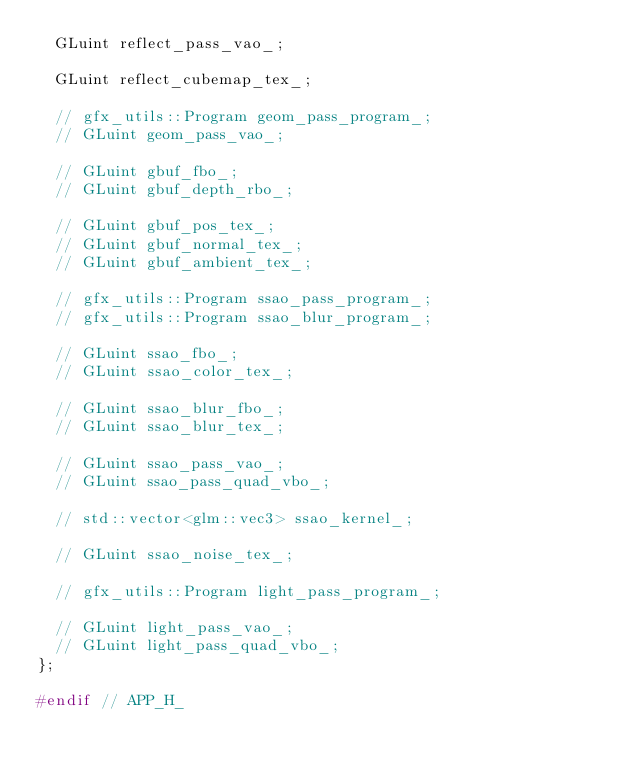Convert code to text. <code><loc_0><loc_0><loc_500><loc_500><_C_>  GLuint reflect_pass_vao_;

  GLuint reflect_cubemap_tex_;

  // gfx_utils::Program geom_pass_program_;
  // GLuint geom_pass_vao_;

  // GLuint gbuf_fbo_;
  // GLuint gbuf_depth_rbo_;

  // GLuint gbuf_pos_tex_;
  // GLuint gbuf_normal_tex_;
  // GLuint gbuf_ambient_tex_;

  // gfx_utils::Program ssao_pass_program_;
  // gfx_utils::Program ssao_blur_program_;

  // GLuint ssao_fbo_;
  // GLuint ssao_color_tex_;

  // GLuint ssao_blur_fbo_;
  // GLuint ssao_blur_tex_;

  // GLuint ssao_pass_vao_;
  // GLuint ssao_pass_quad_vbo_;

  // std::vector<glm::vec3> ssao_kernel_;

  // GLuint ssao_noise_tex_;

  // gfx_utils::Program light_pass_program_;

  // GLuint light_pass_vao_;
  // GLuint light_pass_quad_vbo_;
};

#endif // APP_H_</code> 